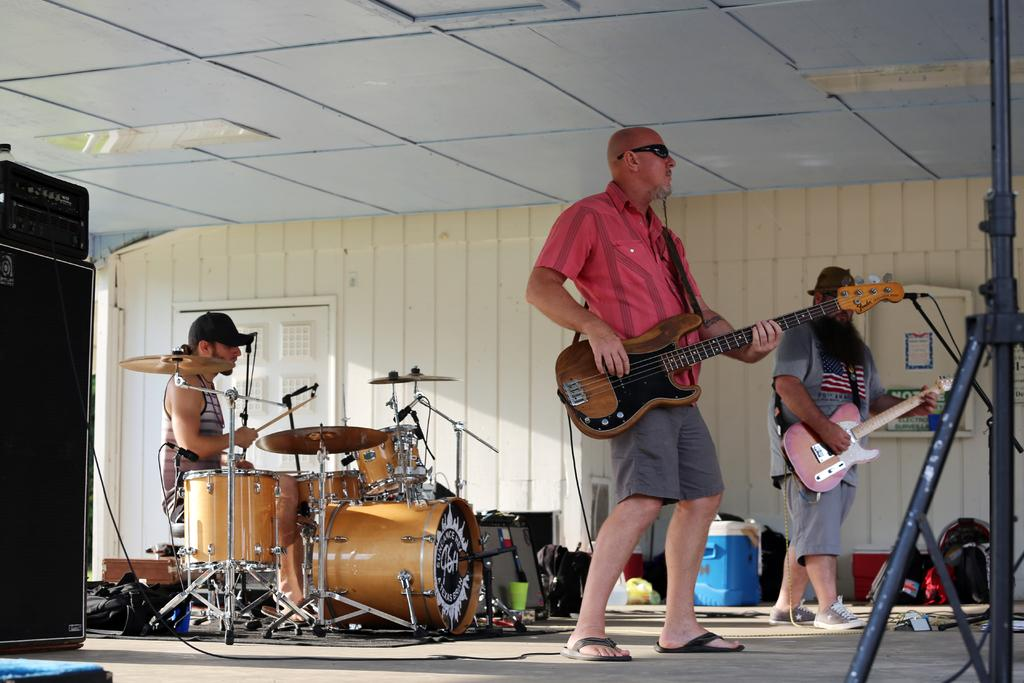What is the man in the image doing? The man is sitting and playing drums. Are there any other people in the image? Yes, there are two men in front of the drummer. What are the two men holding? Each of the two men is holding a guitar. Can you see a hole in the drummer's shirt in the image? There is no mention of a hole in the drummer's shirt in the provided facts, so it cannot be determined from the image. 